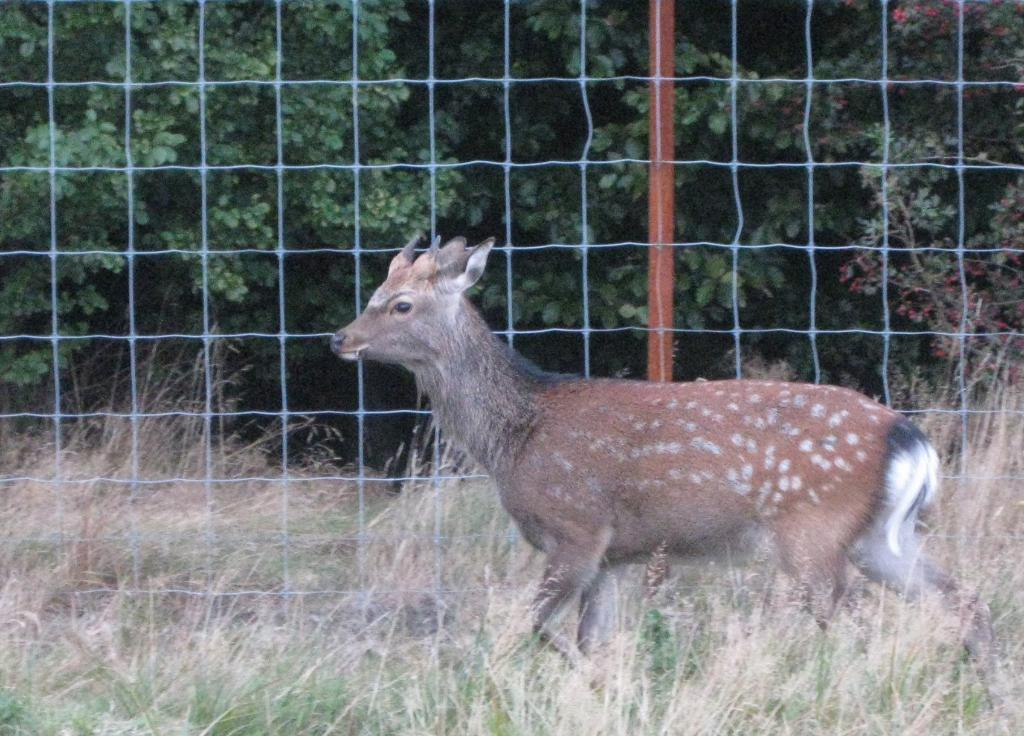What animal is present in the image? There is a fox in the image. What is the fox doing in the image? The fox is walking on the grass. What can be seen in the background of the image? There is a net fence and trees in the background of the image. What type of skirt is the fox wearing in the image? The fox is not wearing a skirt in the image; it is a wild animal. 